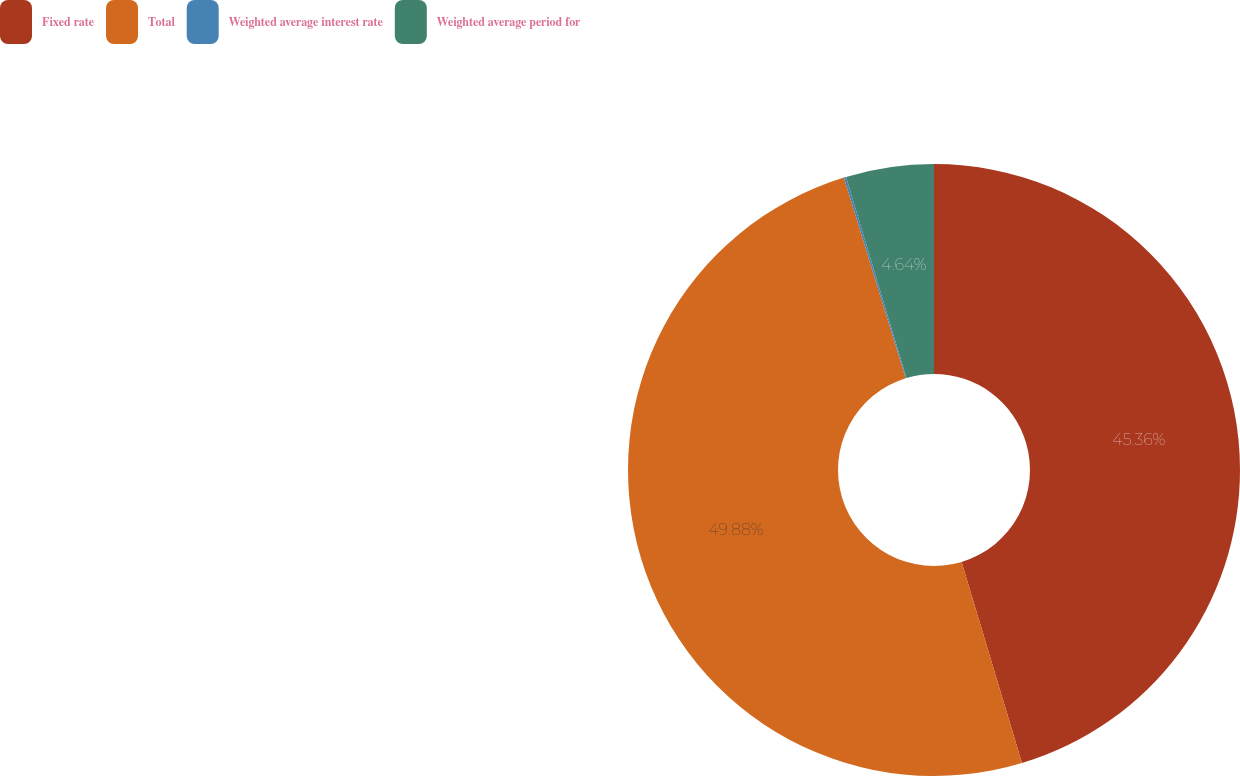Convert chart to OTSL. <chart><loc_0><loc_0><loc_500><loc_500><pie_chart><fcel>Fixed rate<fcel>Total<fcel>Weighted average interest rate<fcel>Weighted average period for<nl><fcel>45.36%<fcel>49.88%<fcel>0.12%<fcel>4.64%<nl></chart> 